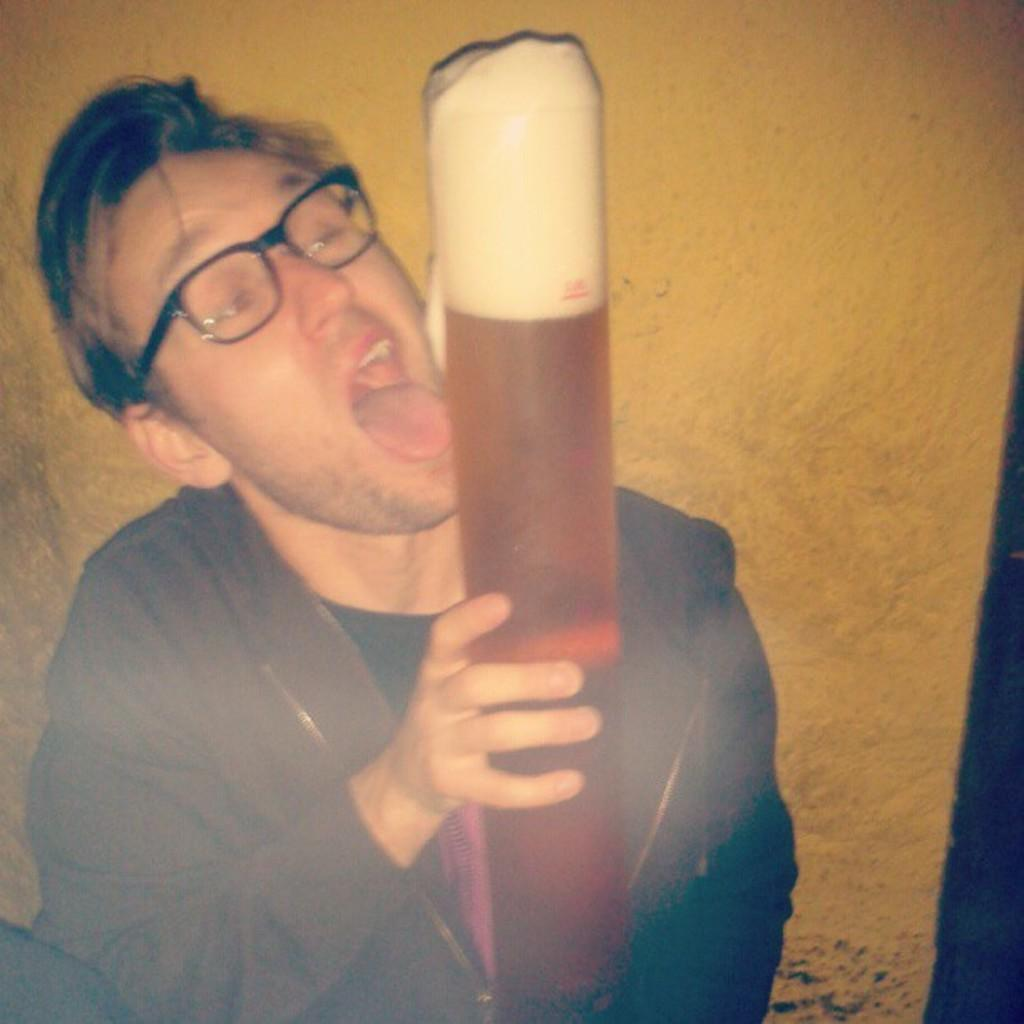What is the person in the image holding? The person is holding a beer glass. What can be seen behind the person in the image? There is a wall visible in the image. What type of joke is the person telling in the image? There is no indication in the image that the person is telling a joke, so it cannot be determined from the picture. 